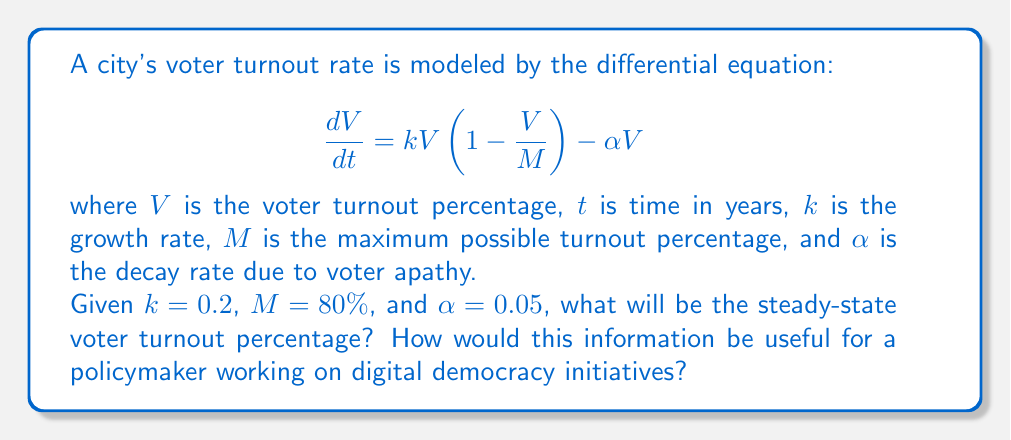Show me your answer to this math problem. To solve this problem, we need to find the steady-state solution of the given differential equation. At steady-state, the rate of change of voter turnout will be zero:

$$\frac{dV}{dt} = 0$$

Substituting this into our original equation:

$$0 = kV(1-\frac{V}{M}) - \alpha V$$

Factoring out $V$:

$$0 = V(k(1-\frac{V}{M}) - \alpha)$$

This equation has two solutions: $V=0$ (trivial solution) and:

$$k(1-\frac{V}{M}) - \alpha = 0$$

Solving for $V$:

$$k - \frac{kV}{M} = \alpha$$
$$k - \alpha = \frac{kV}{M}$$
$$V = \frac{M(k-\alpha)}{k}$$

Now we can substitute the given values:

$$V = \frac{80(0.2-0.05)}{0.2} = 60\%$$

This steady-state solution represents the long-term voter turnout percentage if current trends continue.

For a policymaker working on digital democracy initiatives, this information is valuable because:

1. It provides a baseline for future projections, allowing for the assessment of new policies' effectiveness.
2. It highlights the impact of voter apathy (represented by $\alpha$) on long-term turnout, suggesting areas for targeted interventions.
3. It demonstrates the maximum achievable turnout ($M$) under current conditions, which could inform realistic goal-setting for digital democracy projects.
4. The model can be adjusted to simulate the effects of different digital initiatives on turnout growth rate ($k$) or maximum turnout ($M$), aiding in policy design and evaluation.
Answer: The steady-state voter turnout percentage is 60%. This information can help policymakers set realistic goals, identify areas for intervention, and evaluate the potential impact of digital democracy initiatives on long-term voter engagement. 